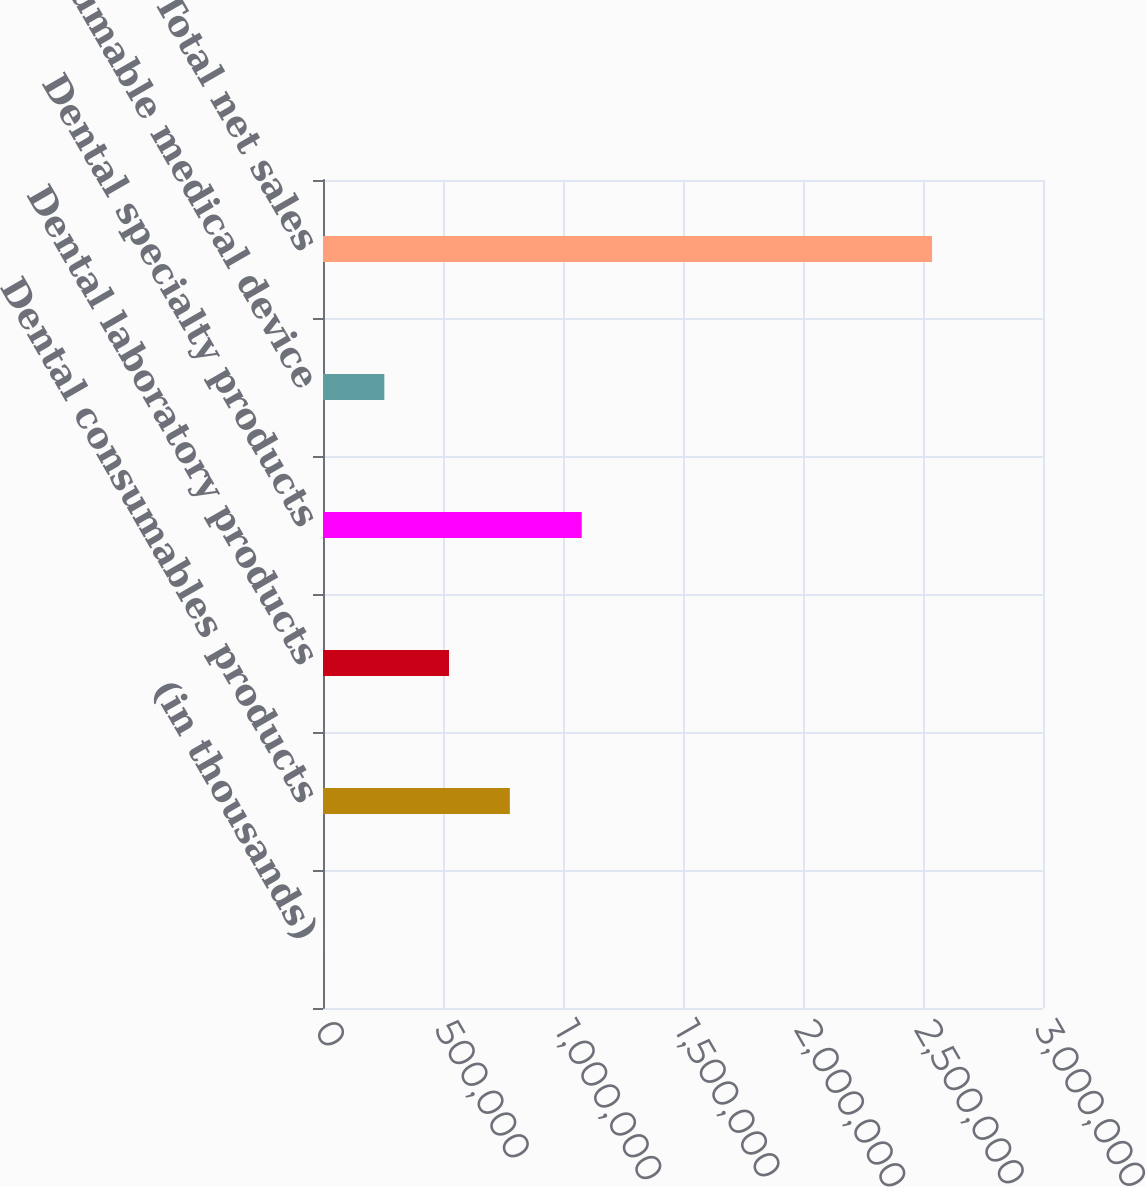Convert chart to OTSL. <chart><loc_0><loc_0><loc_500><loc_500><bar_chart><fcel>(in thousands)<fcel>Dental consumables products<fcel>Dental laboratory products<fcel>Dental specialty products<fcel>Consumable medical device<fcel>Total net sales<nl><fcel>2011<fcel>778579<fcel>525008<fcel>1.07803e+06<fcel>255582<fcel>2.53772e+06<nl></chart> 